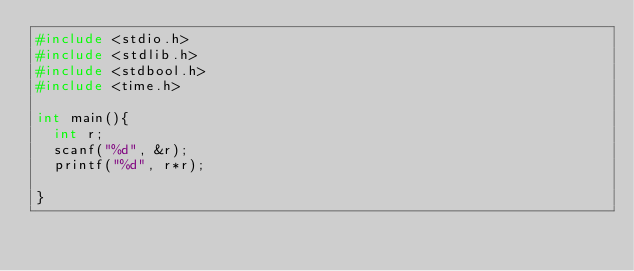<code> <loc_0><loc_0><loc_500><loc_500><_C_>#include <stdio.h>
#include <stdlib.h>
#include <stdbool.h>
#include <time.h>

int main(){
  int r;
  scanf("%d", &r);
  printf("%d", r*r);

}
</code> 